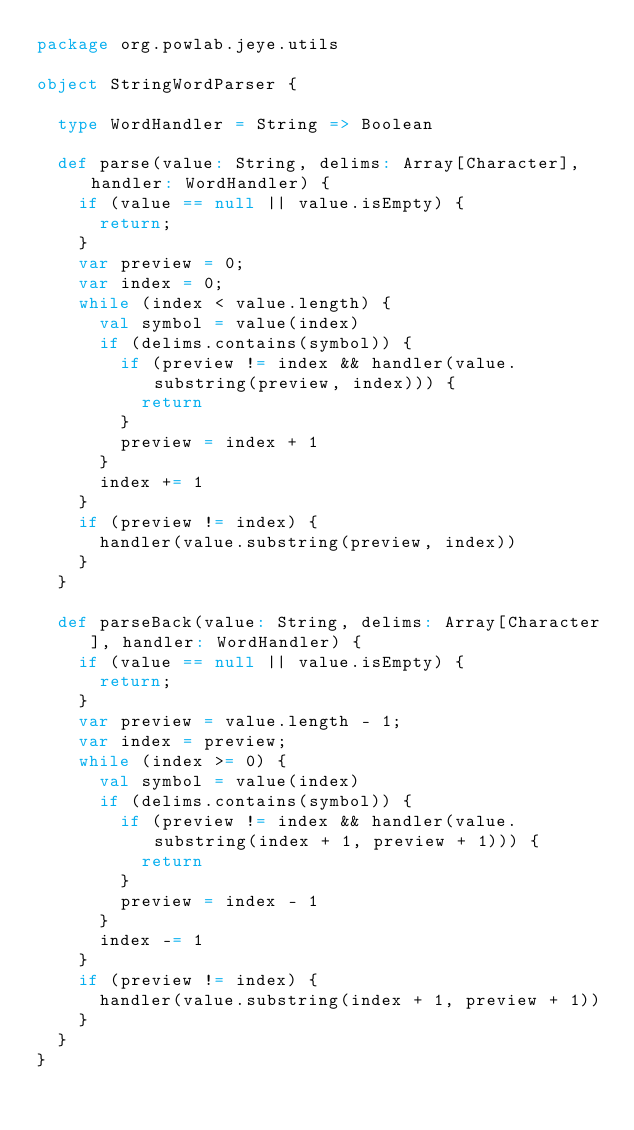Convert code to text. <code><loc_0><loc_0><loc_500><loc_500><_Scala_>package org.powlab.jeye.utils

object StringWordParser {

  type WordHandler = String => Boolean

  def parse(value: String, delims: Array[Character], handler: WordHandler) {
    if (value == null || value.isEmpty) {
      return;
    }
    var preview = 0;
    var index = 0;
    while (index < value.length) {
      val symbol = value(index)
      if (delims.contains(symbol)) {
        if (preview != index && handler(value.substring(preview, index))) {
          return
        }
        preview = index + 1
      }
      index += 1
    }
    if (preview != index) {
      handler(value.substring(preview, index))
    }
  }

  def parseBack(value: String, delims: Array[Character], handler: WordHandler) {
    if (value == null || value.isEmpty) {
      return;
    }
    var preview = value.length - 1;
    var index = preview;
    while (index >= 0) {
      val symbol = value(index)
      if (delims.contains(symbol)) {
        if (preview != index && handler(value.substring(index + 1, preview + 1))) {
          return
        }
        preview = index - 1
      }
      index -= 1
    }
    if (preview != index) {
      handler(value.substring(index + 1, preview + 1))
    }
  }
}
</code> 